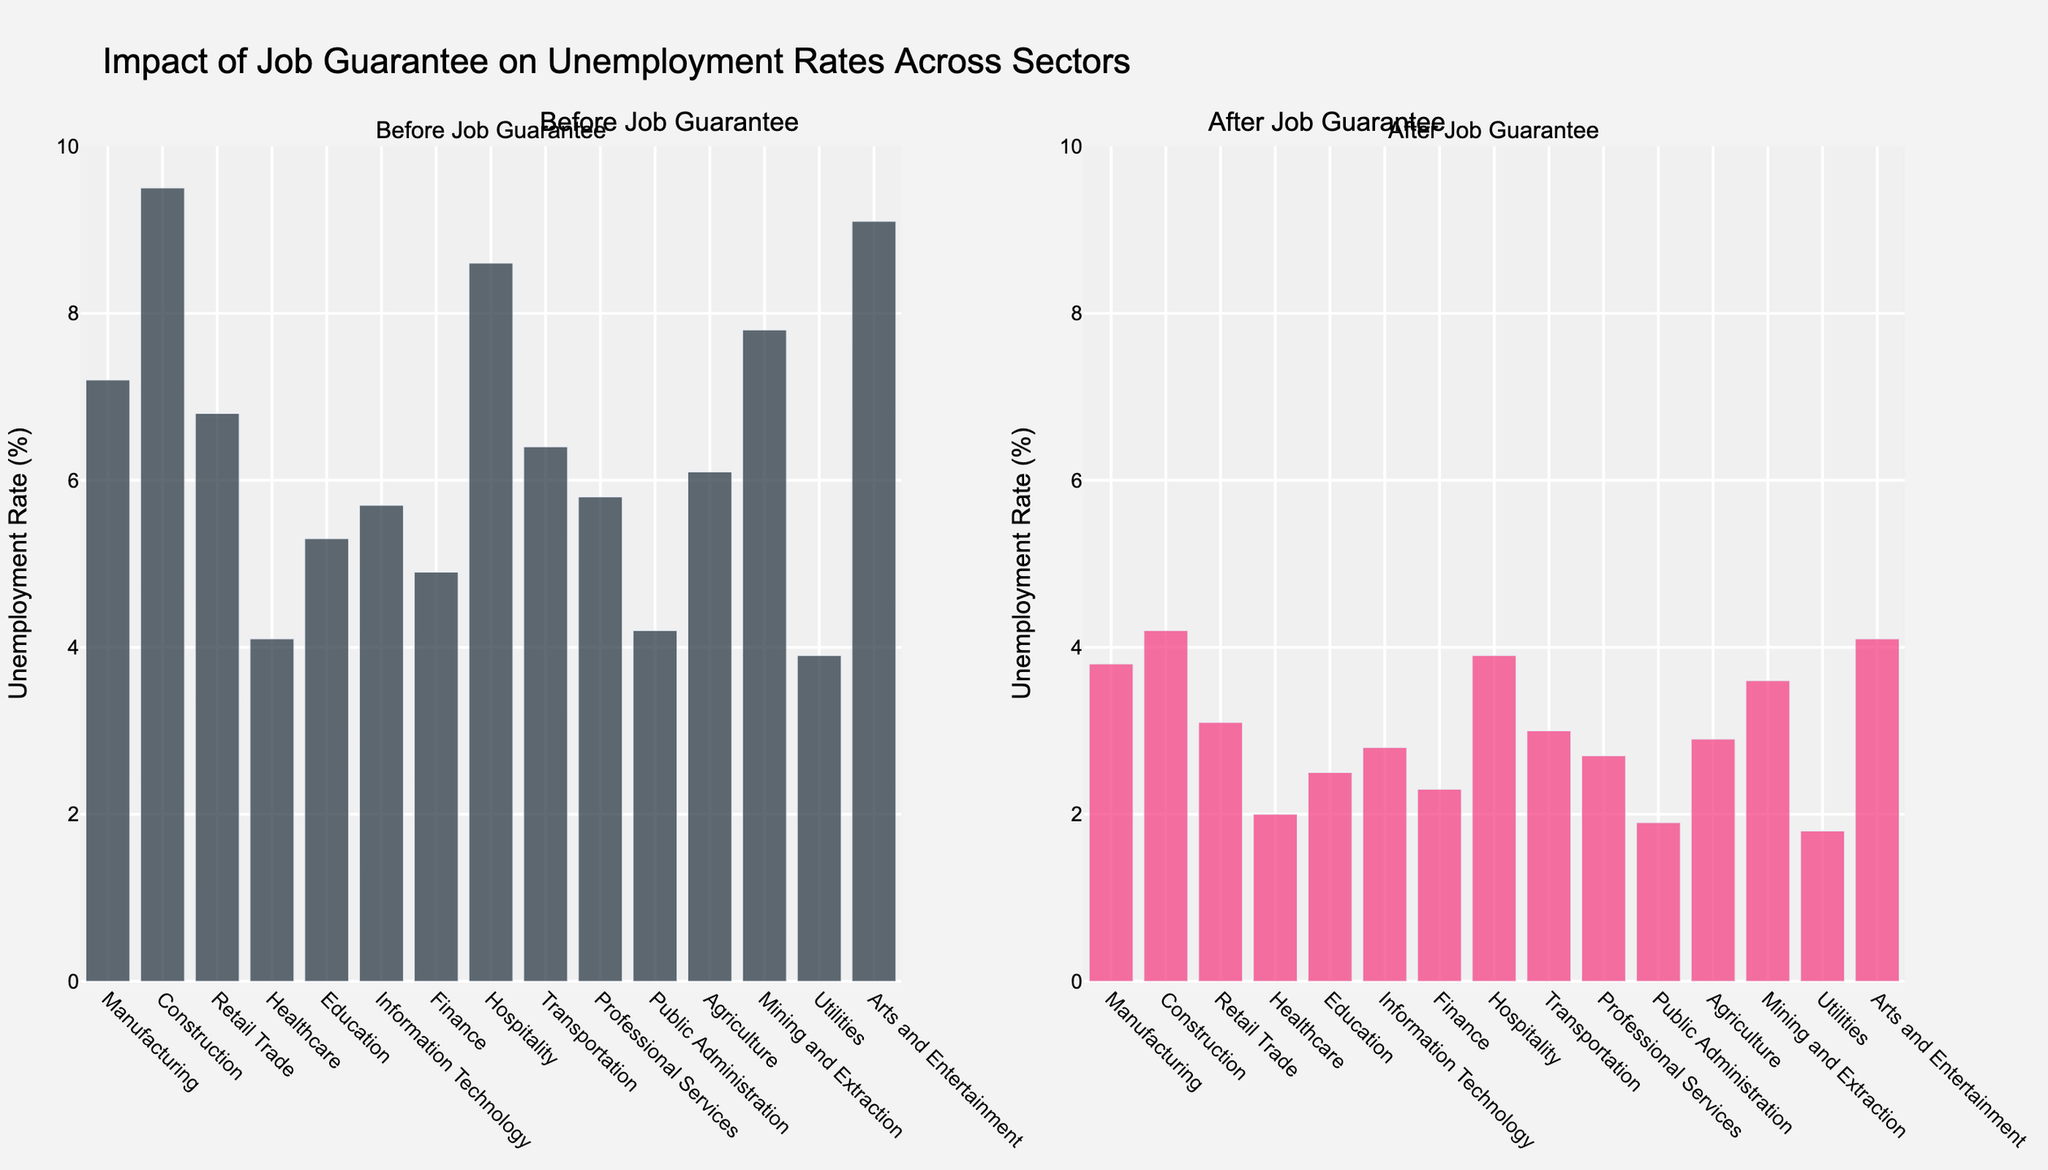Which sector saw the largest decrease in unemployment rate after implementing the job guarantee program? The unemployment rate in the Construction sector decreased from 9.5% to 4.2%, which is a decrease of 5.3 percentage points. To find the largest decrease, we look at the difference between "Before JG" and "After JG" for each sector. Construction had the highest decrease.
Answer: Construction Which sector had the lowest unemployment rate before implementing the job guarantee program? By comparing the "Before JG" values of all sectors, we see that the Utilities sector had the lowest unemployment rate at 3.9%.
Answer: Utilities What was the average unemployment rate across all sectors before the job guarantee program? First, sum up all the "Before JG" unemployment rates: 7.2 + 9.5 + 6.8 + 4.1 + 5.3 + 5.7 + 4.9 + 8.6 + 6.4 + 5.8 + 4.2 + 6.1 + 7.8 + 3.9 + 9.1 = 95.4. Then divide by the number of sectors, which is 15. So, 95.4 / 15 = 6.36.
Answer: 6.36 In which sector did the job guarantee program have the least impact (smallest decrease in unemployment rate)? To find the smallest impact, we calculate the difference between "Before JG" and "After JG" for each sector. The Public Administration sector saw a decrease from 4.2% to 1.9%, a difference of 2.3 percentage points, which is the smallest decrease.
Answer: Public Administration What is the overall percentage reduction in the unemployment rate in the Mining and Extraction sector? The initial unemployment rate in Mining and Extraction was 7.8%, which dropped to 3.6% after the job guarantee. The reduction is 7.8% - 3.6% = 4.2%. The percentage reduction is (4.2 / 7.8) * 100 ≈ 53.85%.
Answer: 53.85% How does the unemployment rate change in Information Technology compare to that in Retail Trade? Before the job guarantee, Information Technology had an unemployment rate of 5.7% which dropped to 2.8%, a decrease of 2.9 percentage points. In Retail Trade, the rate went from 6.8% to 3.1%, a decrease of 3.7 percentage points. The decrease is larger in Retail Trade.
Answer: Retail Trade What is the total unemployment rate reduction across all sectors after the job guarantee program? First, calculate the sum of unemployment rates "Before JG" which is 95.4. Then the sum of "After JG" rates is 46.6. So, the total reduction is 95.4 - 46.6 = 48.8 percentage points.
Answer: 48.8 Which sector has the closest final unemployment rate to 3% after the job guarantee program? After the job guarantee, Transportation has an unemployment rate of 3.0%. This is exactly 3%, making it the closest sector.
Answer: Transportation In how many sectors did the unemployment rate fall below 3% after implementing the job guarantee? Sectors with "After JG" rates below 3% are: Healthcare (2.0%), Education (2.5%), Information Technology (2.8%), Finance (2.3%), Professional Services (2.7%), Public Administration (1.9%), Agriculture (2.9%), Utilities (1.8%). This gives us 8 sectors.
Answer: 8 